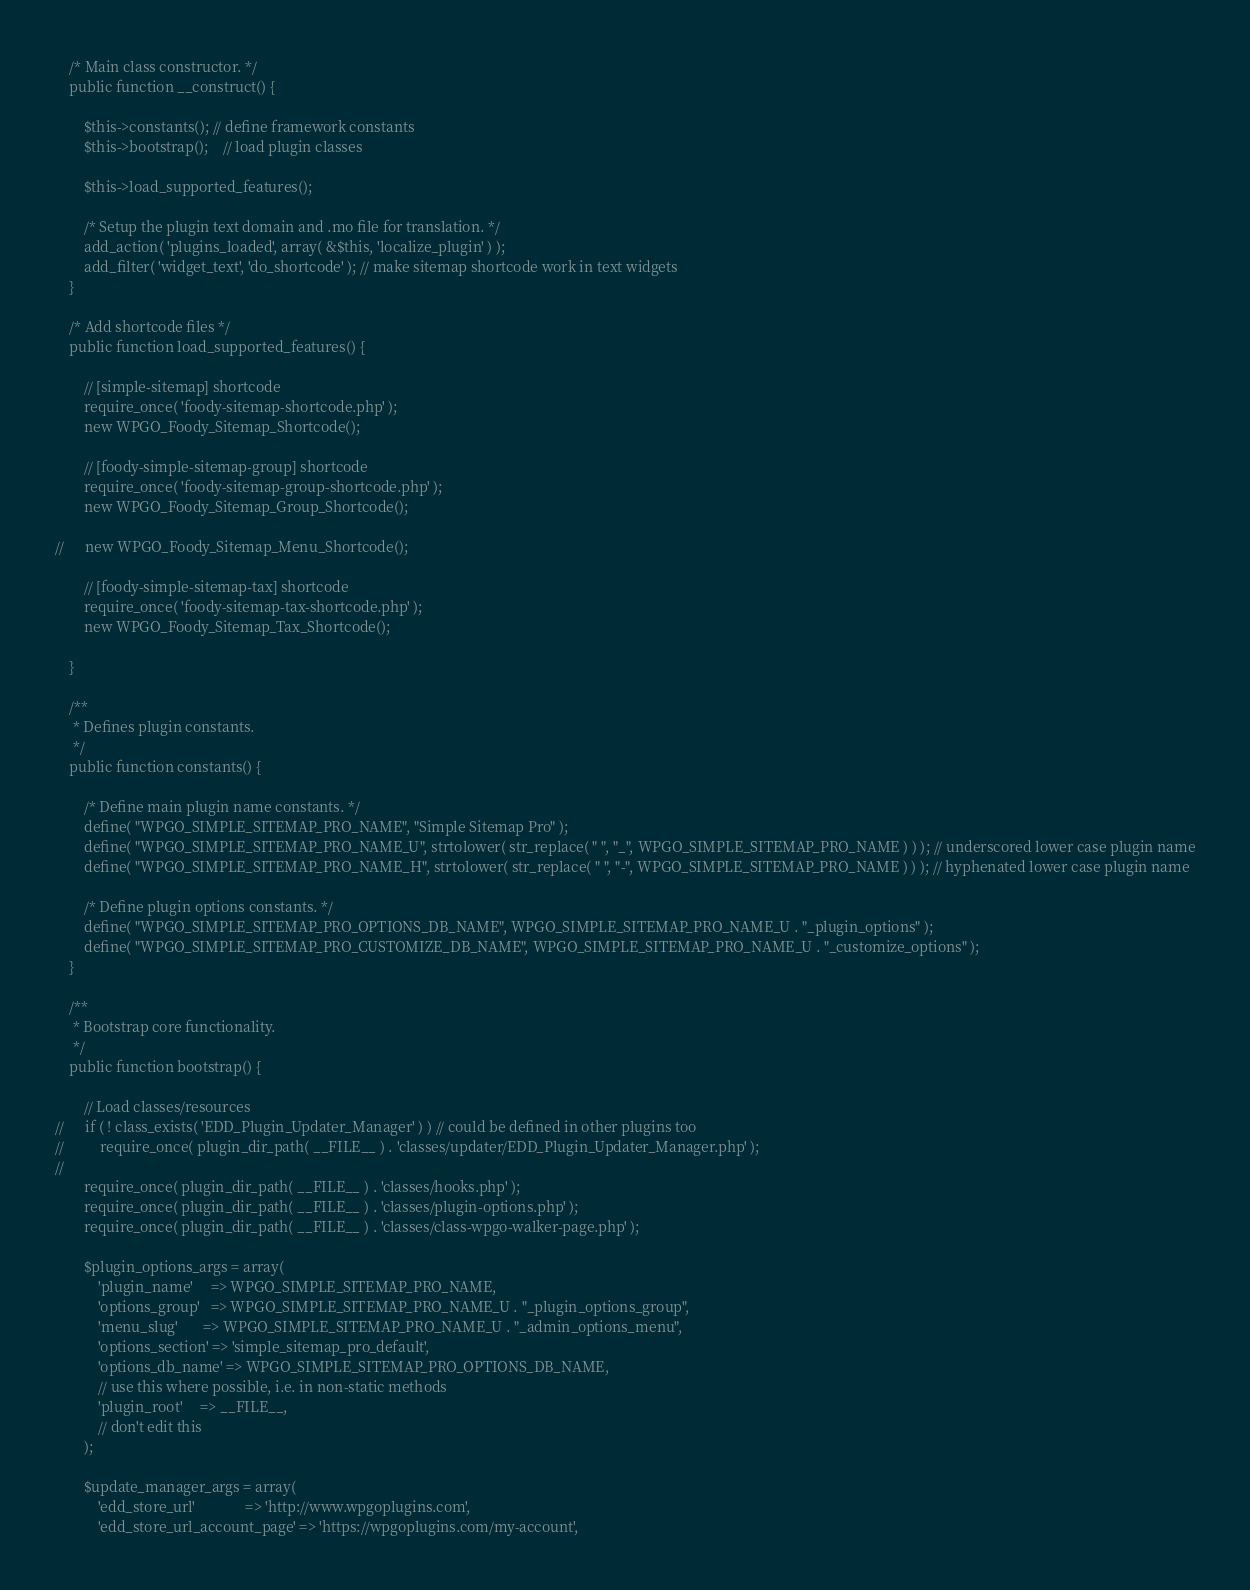Convert code to text. <code><loc_0><loc_0><loc_500><loc_500><_PHP_>
	/* Main class constructor. */
	public function __construct() {

		$this->constants(); // define framework constants
		$this->bootstrap();    // load plugin classes

		$this->load_supported_features();

		/* Setup the plugin text domain and .mo file for translation. */
		add_action( 'plugins_loaded', array( &$this, 'localize_plugin' ) );
		add_filter( 'widget_text', 'do_shortcode' ); // make sitemap shortcode work in text widgets
	}

	/* Add shortcode files */
	public function load_supported_features() {

		// [simple-sitemap] shortcode
		require_once( 'foody-sitemap-shortcode.php' );
		new WPGO_Foody_Sitemap_Shortcode();

		// [foody-simple-sitemap-group] shortcode
		require_once( 'foody-sitemap-group-shortcode.php' );
		new WPGO_Foody_Sitemap_Group_Shortcode();

//		new WPGO_Foody_Sitemap_Menu_Shortcode();

		// [foody-simple-sitemap-tax] shortcode
		require_once( 'foody-sitemap-tax-shortcode.php' );
		new WPGO_Foody_Sitemap_Tax_Shortcode();

	}

	/**
	 * Defines plugin constants.
	 */
	public function constants() {

		/* Define main plugin name constants. */
		define( "WPGO_SIMPLE_SITEMAP_PRO_NAME", "Simple Sitemap Pro" );
		define( "WPGO_SIMPLE_SITEMAP_PRO_NAME_U", strtolower( str_replace( " ", "_", WPGO_SIMPLE_SITEMAP_PRO_NAME ) ) ); // underscored lower case plugin name
		define( "WPGO_SIMPLE_SITEMAP_PRO_NAME_H", strtolower( str_replace( " ", "-", WPGO_SIMPLE_SITEMAP_PRO_NAME ) ) ); // hyphenated lower case plugin name

		/* Define plugin options constants. */
		define( "WPGO_SIMPLE_SITEMAP_PRO_OPTIONS_DB_NAME", WPGO_SIMPLE_SITEMAP_PRO_NAME_U . "_plugin_options" );
		define( "WPGO_SIMPLE_SITEMAP_PRO_CUSTOMIZE_DB_NAME", WPGO_SIMPLE_SITEMAP_PRO_NAME_U . "_customize_options" );
	}

	/**
	 * Bootstrap core functionality.
	 */
	public function bootstrap() {

		// Load classes/resources
//		if ( ! class_exists( 'EDD_Plugin_Updater_Manager' ) ) // could be defined in other plugins too
//			require_once( plugin_dir_path( __FILE__ ) . 'classes/updater/EDD_Plugin_Updater_Manager.php' );
//
		require_once( plugin_dir_path( __FILE__ ) . 'classes/hooks.php' );
		require_once( plugin_dir_path( __FILE__ ) . 'classes/plugin-options.php' );
		require_once( plugin_dir_path( __FILE__ ) . 'classes/class-wpgo-walker-page.php' );

		$plugin_options_args = array(
			'plugin_name'     => WPGO_SIMPLE_SITEMAP_PRO_NAME,
			'options_group'   => WPGO_SIMPLE_SITEMAP_PRO_NAME_U . "_plugin_options_group",
			'menu_slug'       => WPGO_SIMPLE_SITEMAP_PRO_NAME_U . "_admin_options_menu",
			'options_section' => 'simple_sitemap_pro_default',
			'options_db_name' => WPGO_SIMPLE_SITEMAP_PRO_OPTIONS_DB_NAME,
			// use this where possible, i.e. in non-static methods
			'plugin_root'     => __FILE__,
			// don't edit this
		);

		$update_manager_args = array(
			'edd_store_url'              => 'http://www.wpgoplugins.com',
			'edd_store_url_account_page' => 'https://wpgoplugins.com/my-account',</code> 